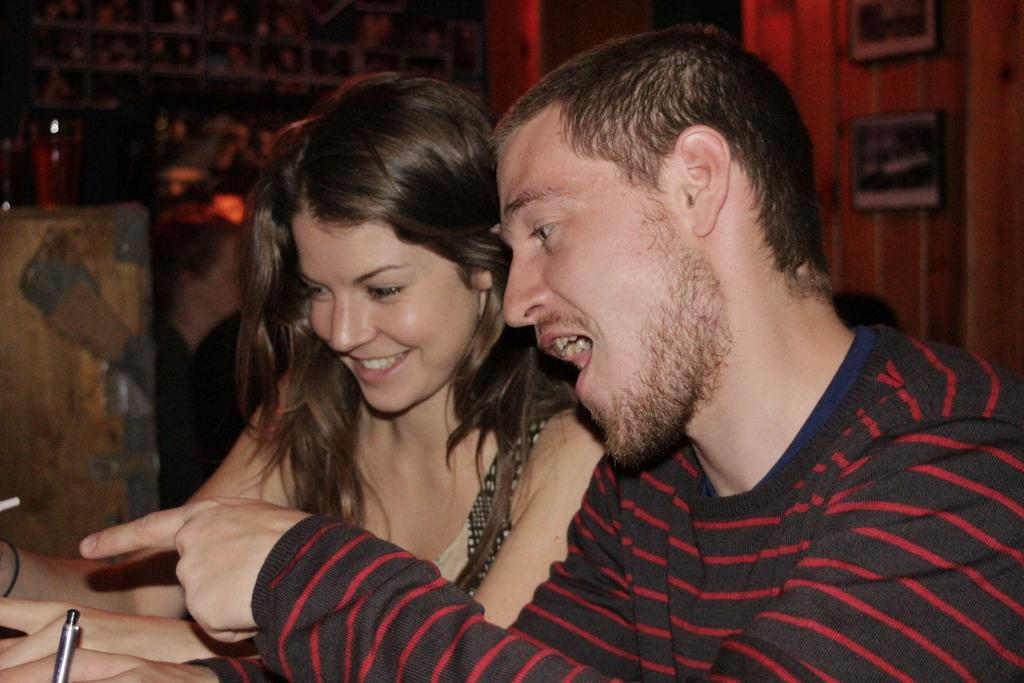How many people are in the image? There are two people in the image, a man and a woman. What are the expressions on their faces? Both the man and woman are smiling in the image. Can you describe the background of the image? The background of the image is slightly blurred and dark. What can be seen on the wall in the background? There are photo frames on the wall in the background. What type of toad can be seen hopping on the man's toes in the image? There is no toad present in the image, and the man's toes are not visible. What pump is being used by the woman in the image? There is no pump visible in the image. 